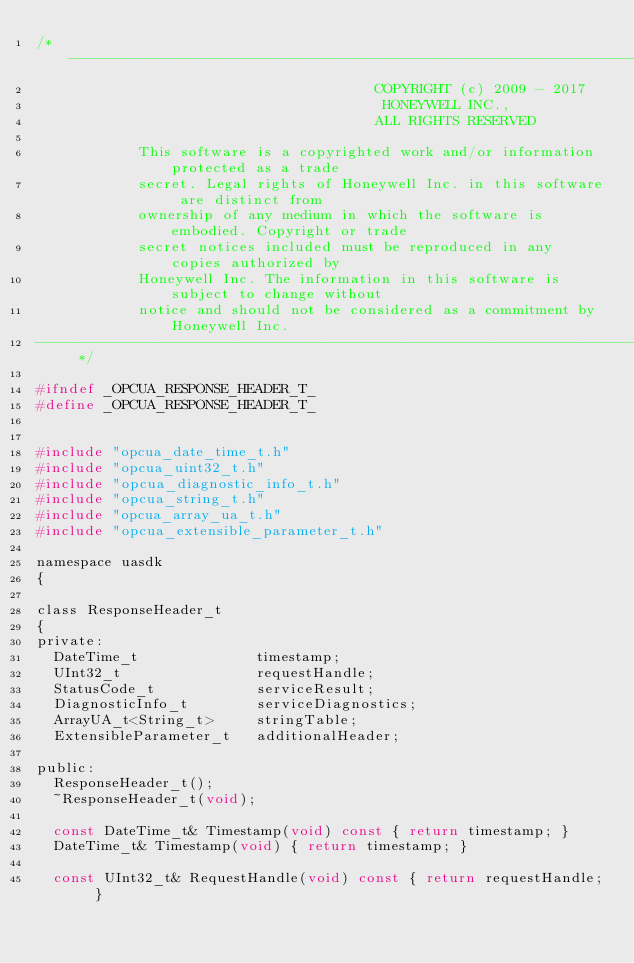<code> <loc_0><loc_0><loc_500><loc_500><_C_>/* -----------------------------------------------------------------------------------------------------------------
                                        COPYRIGHT (c) 2009 - 2017
                                         HONEYWELL INC.,
                                        ALL RIGHTS RESERVED

            This software is a copyrighted work and/or information protected as a trade
            secret. Legal rights of Honeywell Inc. in this software are distinct from
            ownership of any medium in which the software is embodied. Copyright or trade
            secret notices included must be reproduced in any copies authorized by
            Honeywell Inc. The information in this software is subject to change without
            notice and should not be considered as a commitment by Honeywell Inc.
----------------------------------------------------------------------------------------------------------------- */

#ifndef _OPCUA_RESPONSE_HEADER_T_
#define _OPCUA_RESPONSE_HEADER_T_


#include "opcua_date_time_t.h"
#include "opcua_uint32_t.h"
#include "opcua_diagnostic_info_t.h"
#include "opcua_string_t.h"
#include "opcua_array_ua_t.h"
#include "opcua_extensible_parameter_t.h"

namespace uasdk
{

class ResponseHeader_t
{
private:
  DateTime_t              timestamp;
  UInt32_t                requestHandle;
  StatusCode_t            serviceResult;
  DiagnosticInfo_t        serviceDiagnostics;
  ArrayUA_t<String_t>     stringTable;
  ExtensibleParameter_t   additionalHeader;

public:
  ResponseHeader_t();
  ~ResponseHeader_t(void);

  const DateTime_t& Timestamp(void) const { return timestamp; }
  DateTime_t& Timestamp(void) { return timestamp; }

  const UInt32_t& RequestHandle(void) const { return requestHandle; }</code> 